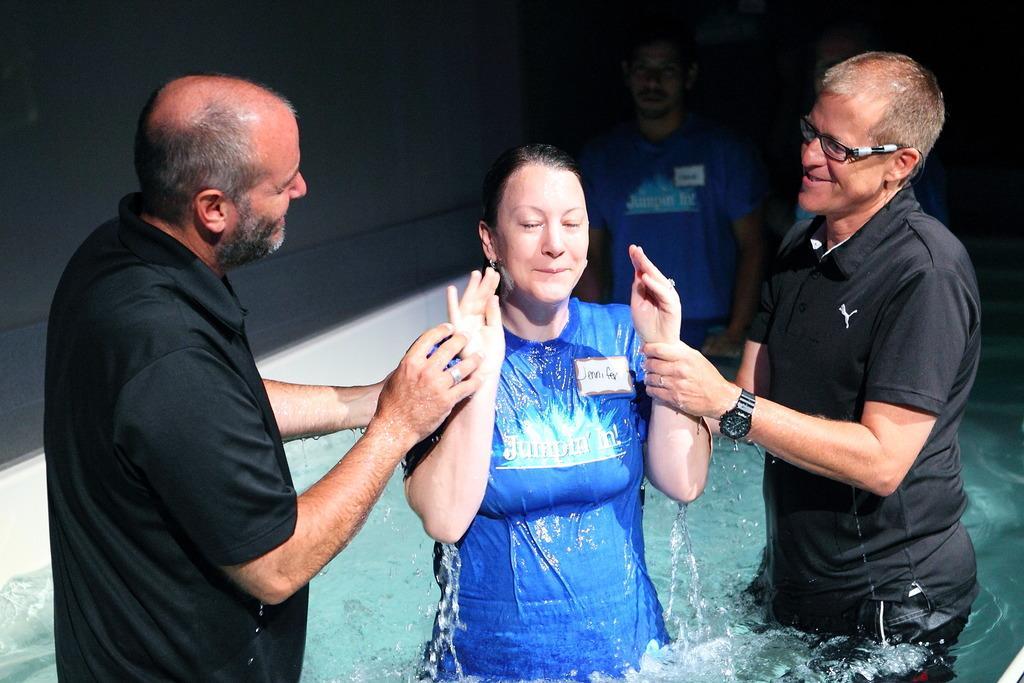In one or two sentences, can you explain what this image depicts? In the picture there are four people standing in a water tub, in the front there is a woman she is completely wet and two men wear holding the woman, in the background there is a wall. 